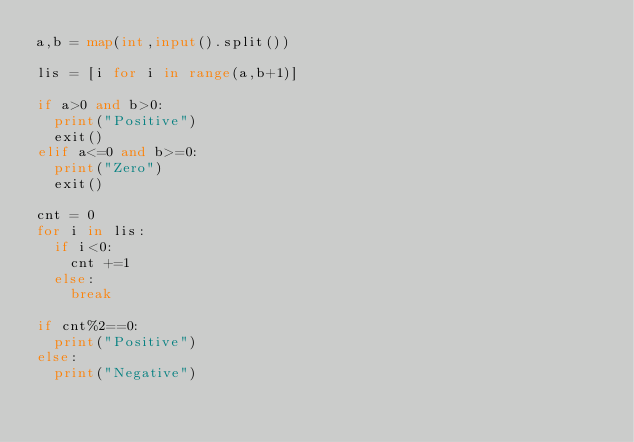Convert code to text. <code><loc_0><loc_0><loc_500><loc_500><_Python_>a,b = map(int,input().split())

lis = [i for i in range(a,b+1)]

if a>0 and b>0:
  print("Positive")
  exit()
elif a<=0 and b>=0:
  print("Zero")
  exit()

cnt = 0
for i in lis:
  if i<0:
    cnt +=1
  else:
    break
    
if cnt%2==0:
  print("Positive")
else:
  print("Negative")</code> 